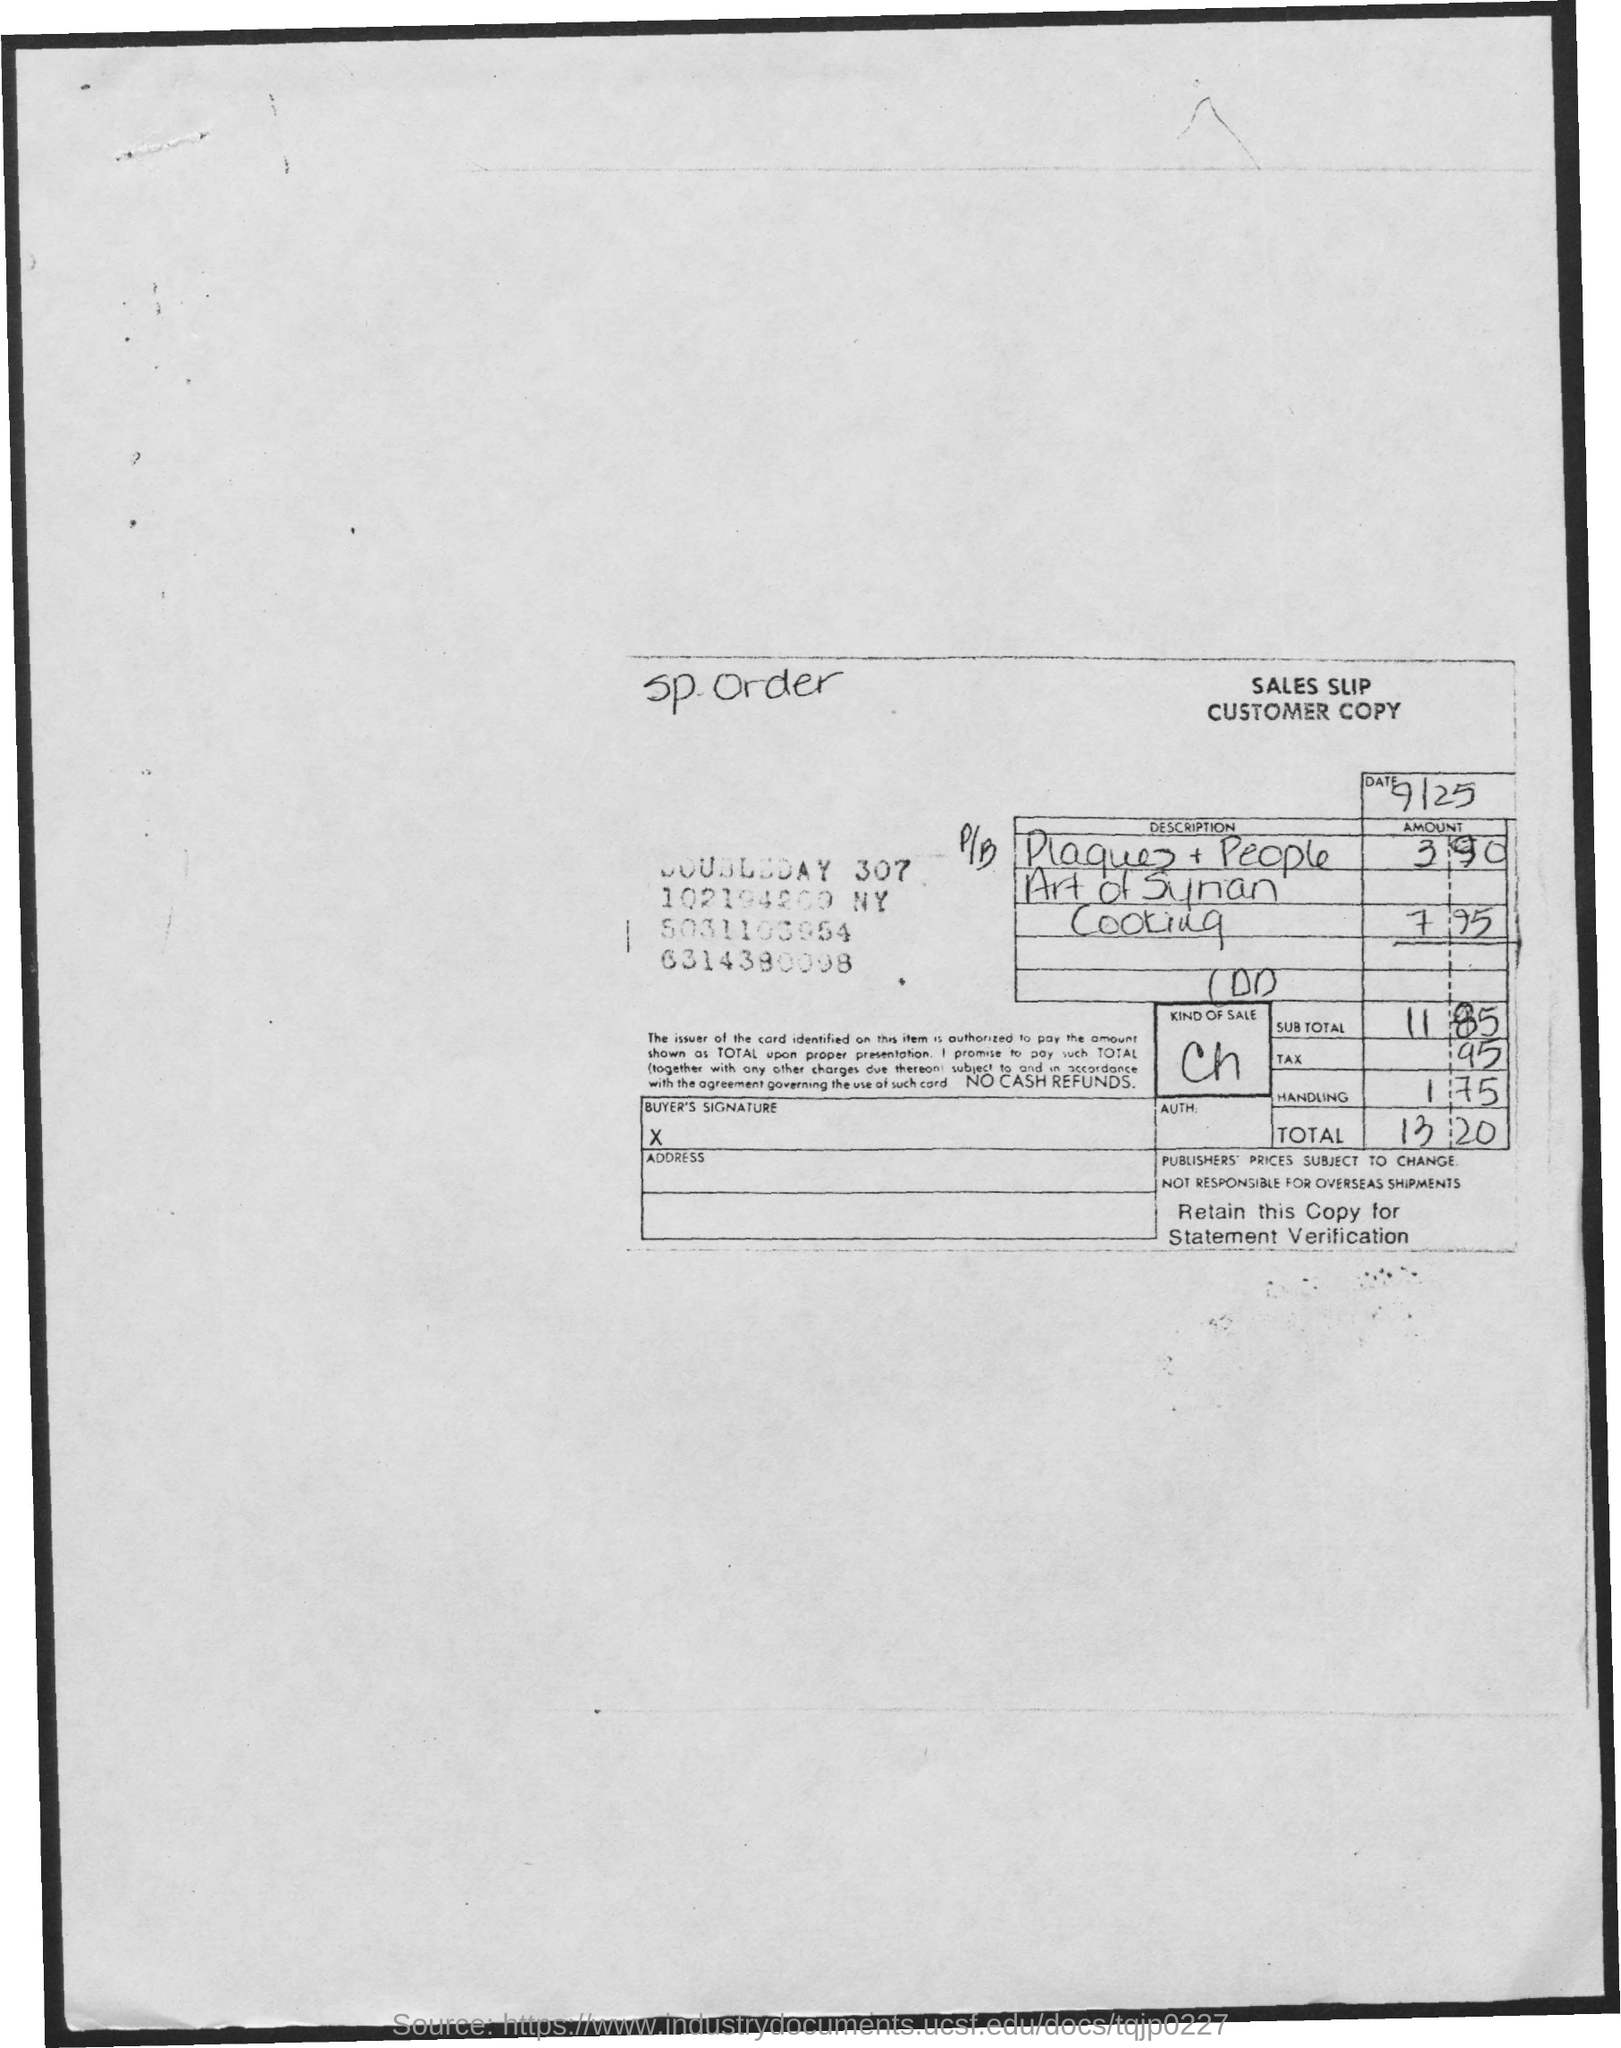Identify some key points in this picture. The sales slip provides information regarding the type of sales being made. The sales slip mentioned the date as September 25th. 